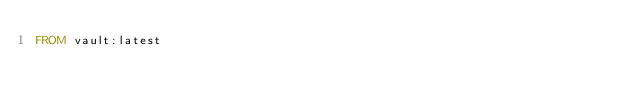<code> <loc_0><loc_0><loc_500><loc_500><_Dockerfile_>FROM vault:latest
</code> 